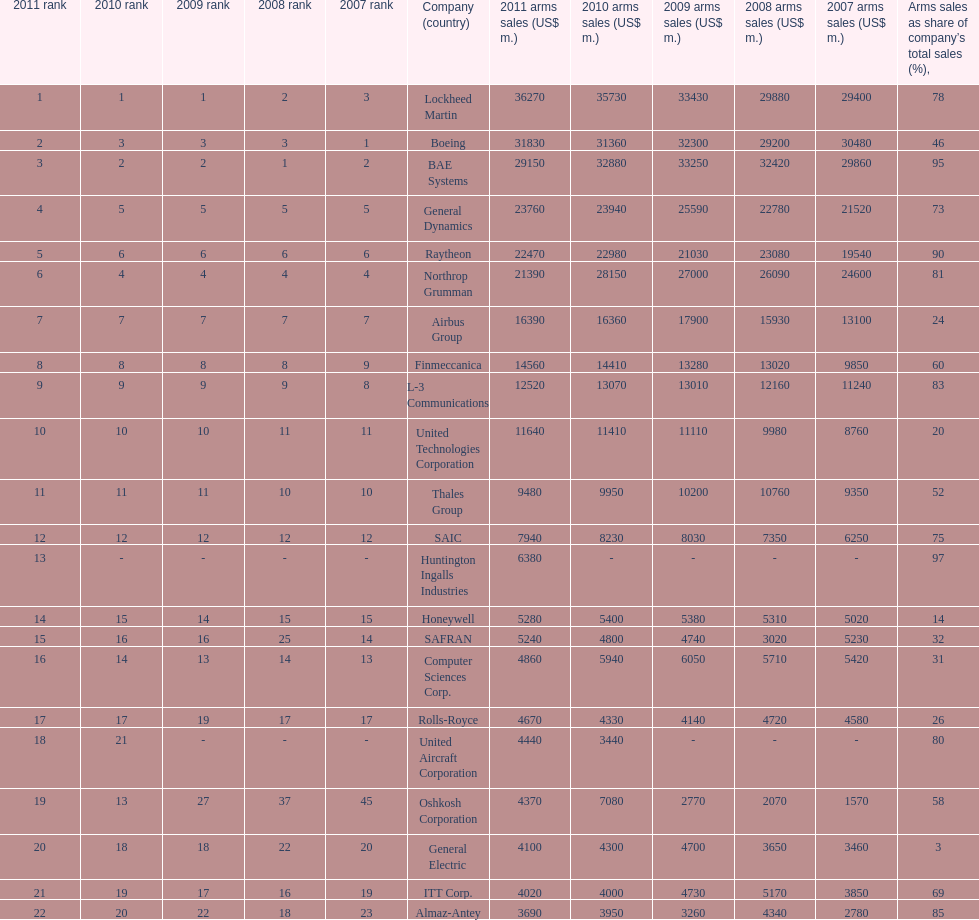I'm looking to parse the entire table for insights. Could you assist me with that? {'header': ['2011 rank', '2010 rank', '2009 rank', '2008 rank', '2007 rank', 'Company (country)', '2011 arms sales (US$ m.)', '2010 arms sales (US$ m.)', '2009 arms sales (US$ m.)', '2008 arms sales (US$ m.)', '2007 arms sales (US$ m.)', 'Arms sales as share of company’s total sales (%),'], 'rows': [['1', '1', '1', '2', '3', 'Lockheed Martin', '36270', '35730', '33430', '29880', '29400', '78'], ['2', '3', '3', '3', '1', 'Boeing', '31830', '31360', '32300', '29200', '30480', '46'], ['3', '2', '2', '1', '2', 'BAE Systems', '29150', '32880', '33250', '32420', '29860', '95'], ['4', '5', '5', '5', '5', 'General Dynamics', '23760', '23940', '25590', '22780', '21520', '73'], ['5', '6', '6', '6', '6', 'Raytheon', '22470', '22980', '21030', '23080', '19540', '90'], ['6', '4', '4', '4', '4', 'Northrop Grumman', '21390', '28150', '27000', '26090', '24600', '81'], ['7', '7', '7', '7', '7', 'Airbus Group', '16390', '16360', '17900', '15930', '13100', '24'], ['8', '8', '8', '8', '9', 'Finmeccanica', '14560', '14410', '13280', '13020', '9850', '60'], ['9', '9', '9', '9', '8', 'L-3 Communications', '12520', '13070', '13010', '12160', '11240', '83'], ['10', '10', '10', '11', '11', 'United Technologies Corporation', '11640', '11410', '11110', '9980', '8760', '20'], ['11', '11', '11', '10', '10', 'Thales Group', '9480', '9950', '10200', '10760', '9350', '52'], ['12', '12', '12', '12', '12', 'SAIC', '7940', '8230', '8030', '7350', '6250', '75'], ['13', '-', '-', '-', '-', 'Huntington Ingalls Industries', '6380', '-', '-', '-', '-', '97'], ['14', '15', '14', '15', '15', 'Honeywell', '5280', '5400', '5380', '5310', '5020', '14'], ['15', '16', '16', '25', '14', 'SAFRAN', '5240', '4800', '4740', '3020', '5230', '32'], ['16', '14', '13', '14', '13', 'Computer Sciences Corp.', '4860', '5940', '6050', '5710', '5420', '31'], ['17', '17', '19', '17', '17', 'Rolls-Royce', '4670', '4330', '4140', '4720', '4580', '26'], ['18', '21', '-', '-', '-', 'United Aircraft Corporation', '4440', '3440', '-', '-', '-', '80'], ['19', '13', '27', '37', '45', 'Oshkosh Corporation', '4370', '7080', '2770', '2070', '1570', '58'], ['20', '18', '18', '22', '20', 'General Electric', '4100', '4300', '4700', '3650', '3460', '3'], ['21', '19', '17', '16', '19', 'ITT Corp.', '4020', '4000', '4730', '5170', '3850', '69'], ['22', '20', '22', '18', '23', 'Almaz-Antey', '3690', '3950', '3260', '4340', '2780', '85']]} Which company had the highest 2009 arms sales? Lockheed Martin. 